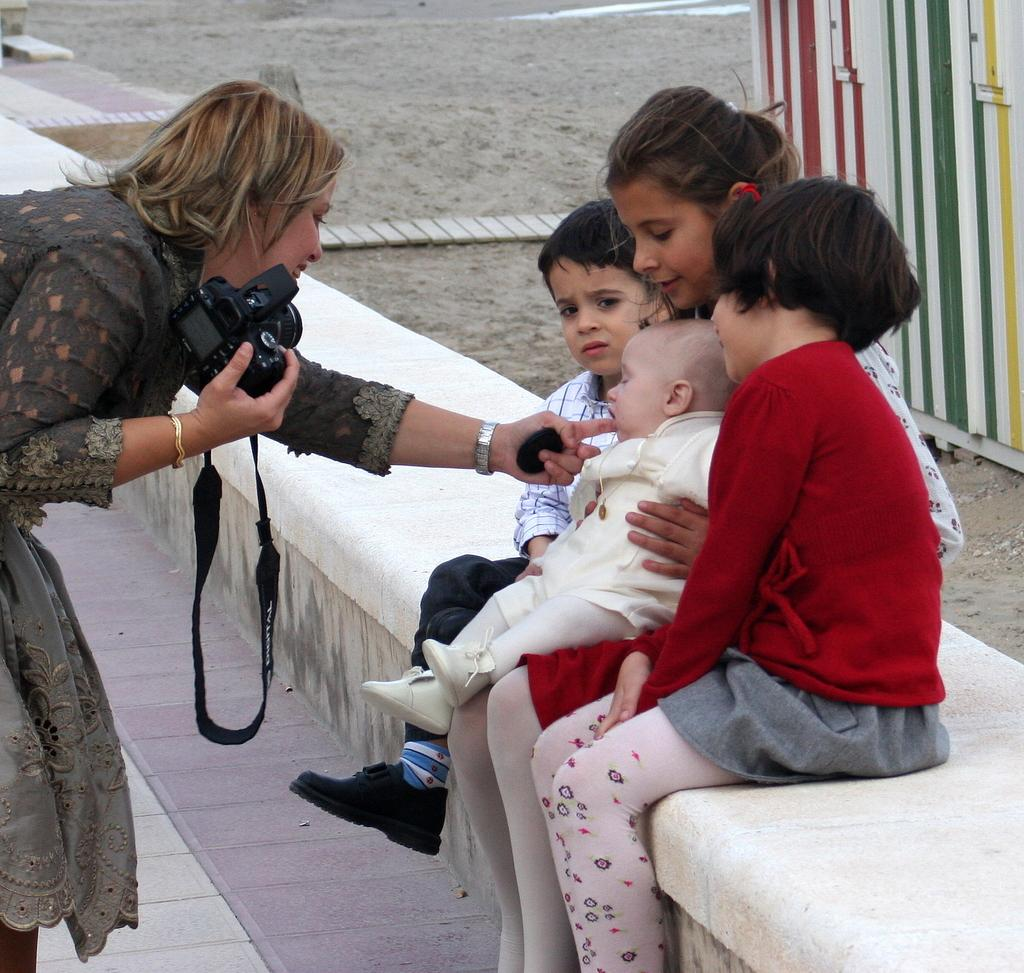How many people are sitting together in the image? There are four persons sitting on a stone in the center of the image. Can you describe the woman on the left side of the image? The woman is smiling and holding a camera. What type of surface can be seen in the background of the image? There is sand visible in the background of the image. What else can be seen in the background of the image? There are additional objects in the background of the image. What type of wall can be seen in the image? There is no wall present in the image. Is there a gun visible in the hands of any of the persons in the image? No, there are no guns visible in the image. 